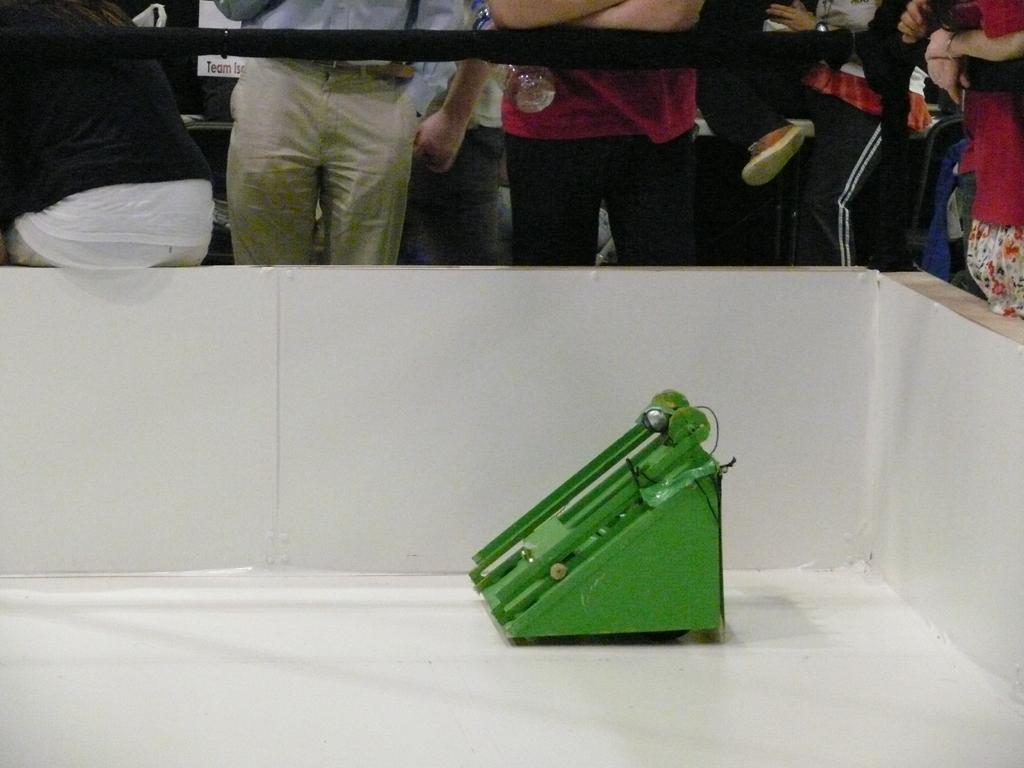What is the color of the device in the image? The device in the image is green. Where is the device located in the image? The device is placed on the floor. What is the color of the wall in the image? The wall in the image is white. What is the color of the railing in the image? The railing in the image is black. Who can be seen behind the railing in the image? There are people standing behind the railing in the image. What type of pen can be seen in the wilderness in the image? There is no pen or wilderness present in the image. 